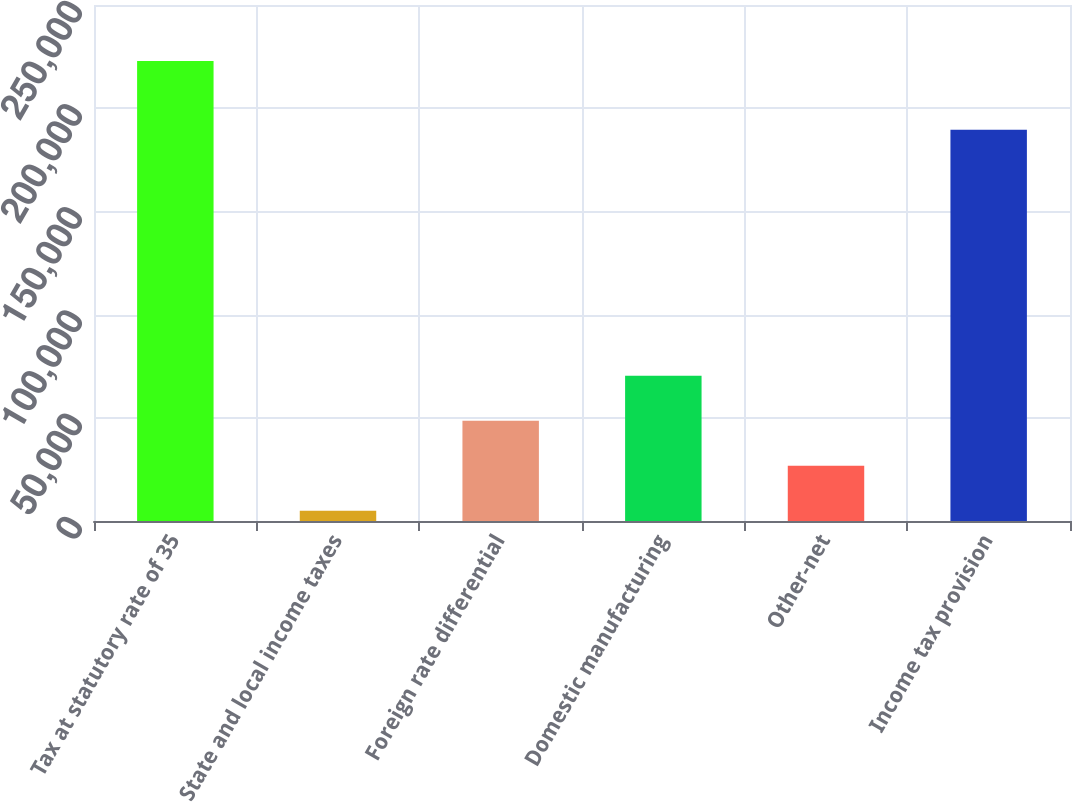Convert chart to OTSL. <chart><loc_0><loc_0><loc_500><loc_500><bar_chart><fcel>Tax at statutory rate of 35<fcel>State and local income taxes<fcel>Foreign rate differential<fcel>Domestic manufacturing<fcel>Other-net<fcel>Income tax provision<nl><fcel>222888<fcel>4931<fcel>48522.4<fcel>70318.1<fcel>26726.7<fcel>189612<nl></chart> 